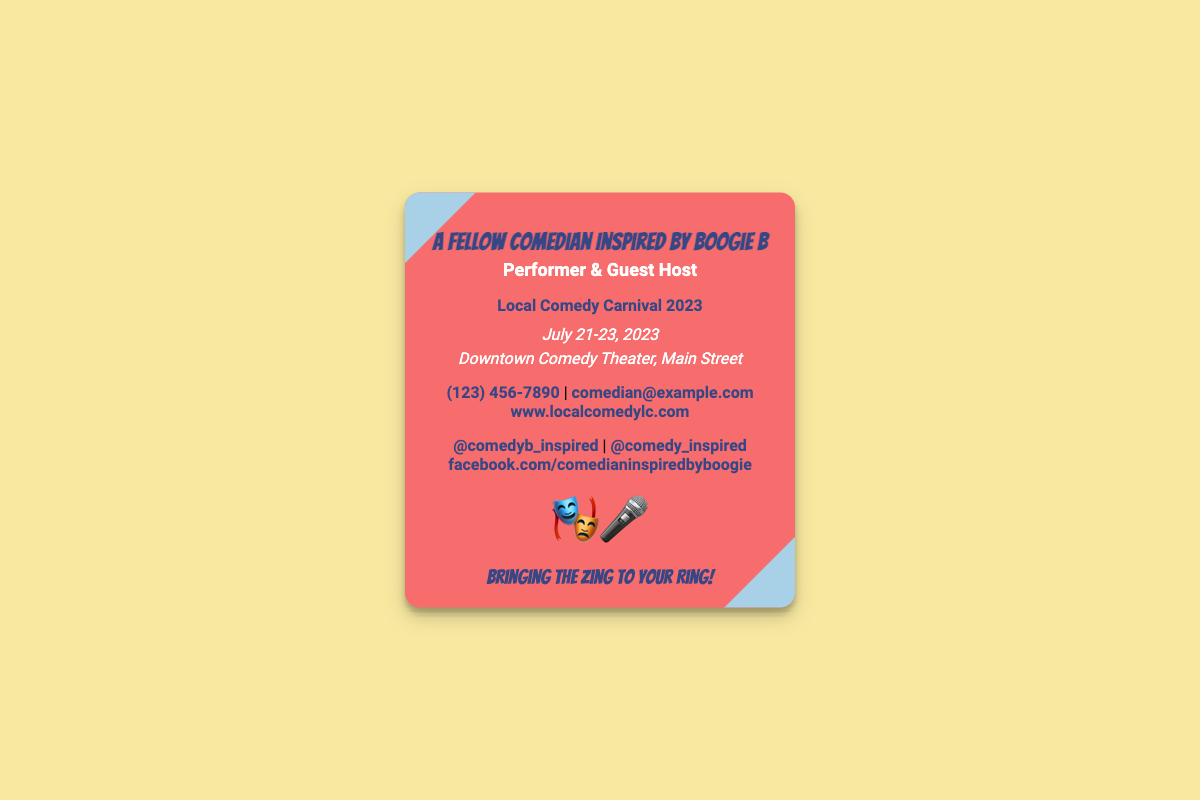what is the name of the performer? The name of the performer is provided at the top of the business card.
Answer: A Fellow Comedian Inspired by Boogie B what is the role listed on the business card? The role is listed below the name on the business card.
Answer: Performer & Guest Host what are the dates of the comedy festival? The dates of the festival are displayed prominently on the card.
Answer: July 21-23, 2023 where is the Local Comedy Carnival located? The location is mentioned under the dates section on the business card.
Answer: Downtown Comedy Theater, Main Street what is the website for the comedy festival? The website can be found in the contact section of the business card.
Answer: www.localcomedylc.com how many social media links are provided? The business card lists several social media platforms.
Answer: Three what type of event is highlighted on the business card? The event is indicated by the title and context given on the card.
Answer: Comedy Carnival what tagline is included on the business card? The tagline is mentioned near the bottom of the card.
Answer: Bringing the Zing to Your Ring! what logo icons are used on the card? The logo consists of icons that represent the theme of the card.
Answer: 🎭🎤 